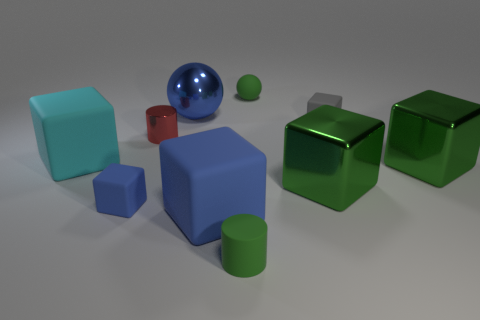What number of other things are the same shape as the gray matte object?
Provide a succinct answer. 5. What number of small spheres have the same material as the cyan object?
Offer a terse response. 1. Are there any large cyan rubber cubes to the right of the small matte cube right of the small green object in front of the big blue cube?
Your answer should be compact. No. The big cyan thing that is made of the same material as the tiny gray object is what shape?
Make the answer very short. Cube. Are there more blue balls than tiny purple things?
Provide a succinct answer. Yes. Does the red object have the same shape as the small matte thing that is in front of the tiny blue thing?
Your answer should be very brief. Yes. What is the cyan block made of?
Your response must be concise. Rubber. There is a tiny sphere that is on the right side of the big metal thing behind the matte cube that is behind the tiny red cylinder; what color is it?
Ensure brevity in your answer.  Green. What is the material of the small gray object that is the same shape as the cyan thing?
Provide a succinct answer. Rubber. What number of green metal objects are the same size as the cyan matte block?
Offer a terse response. 2. 